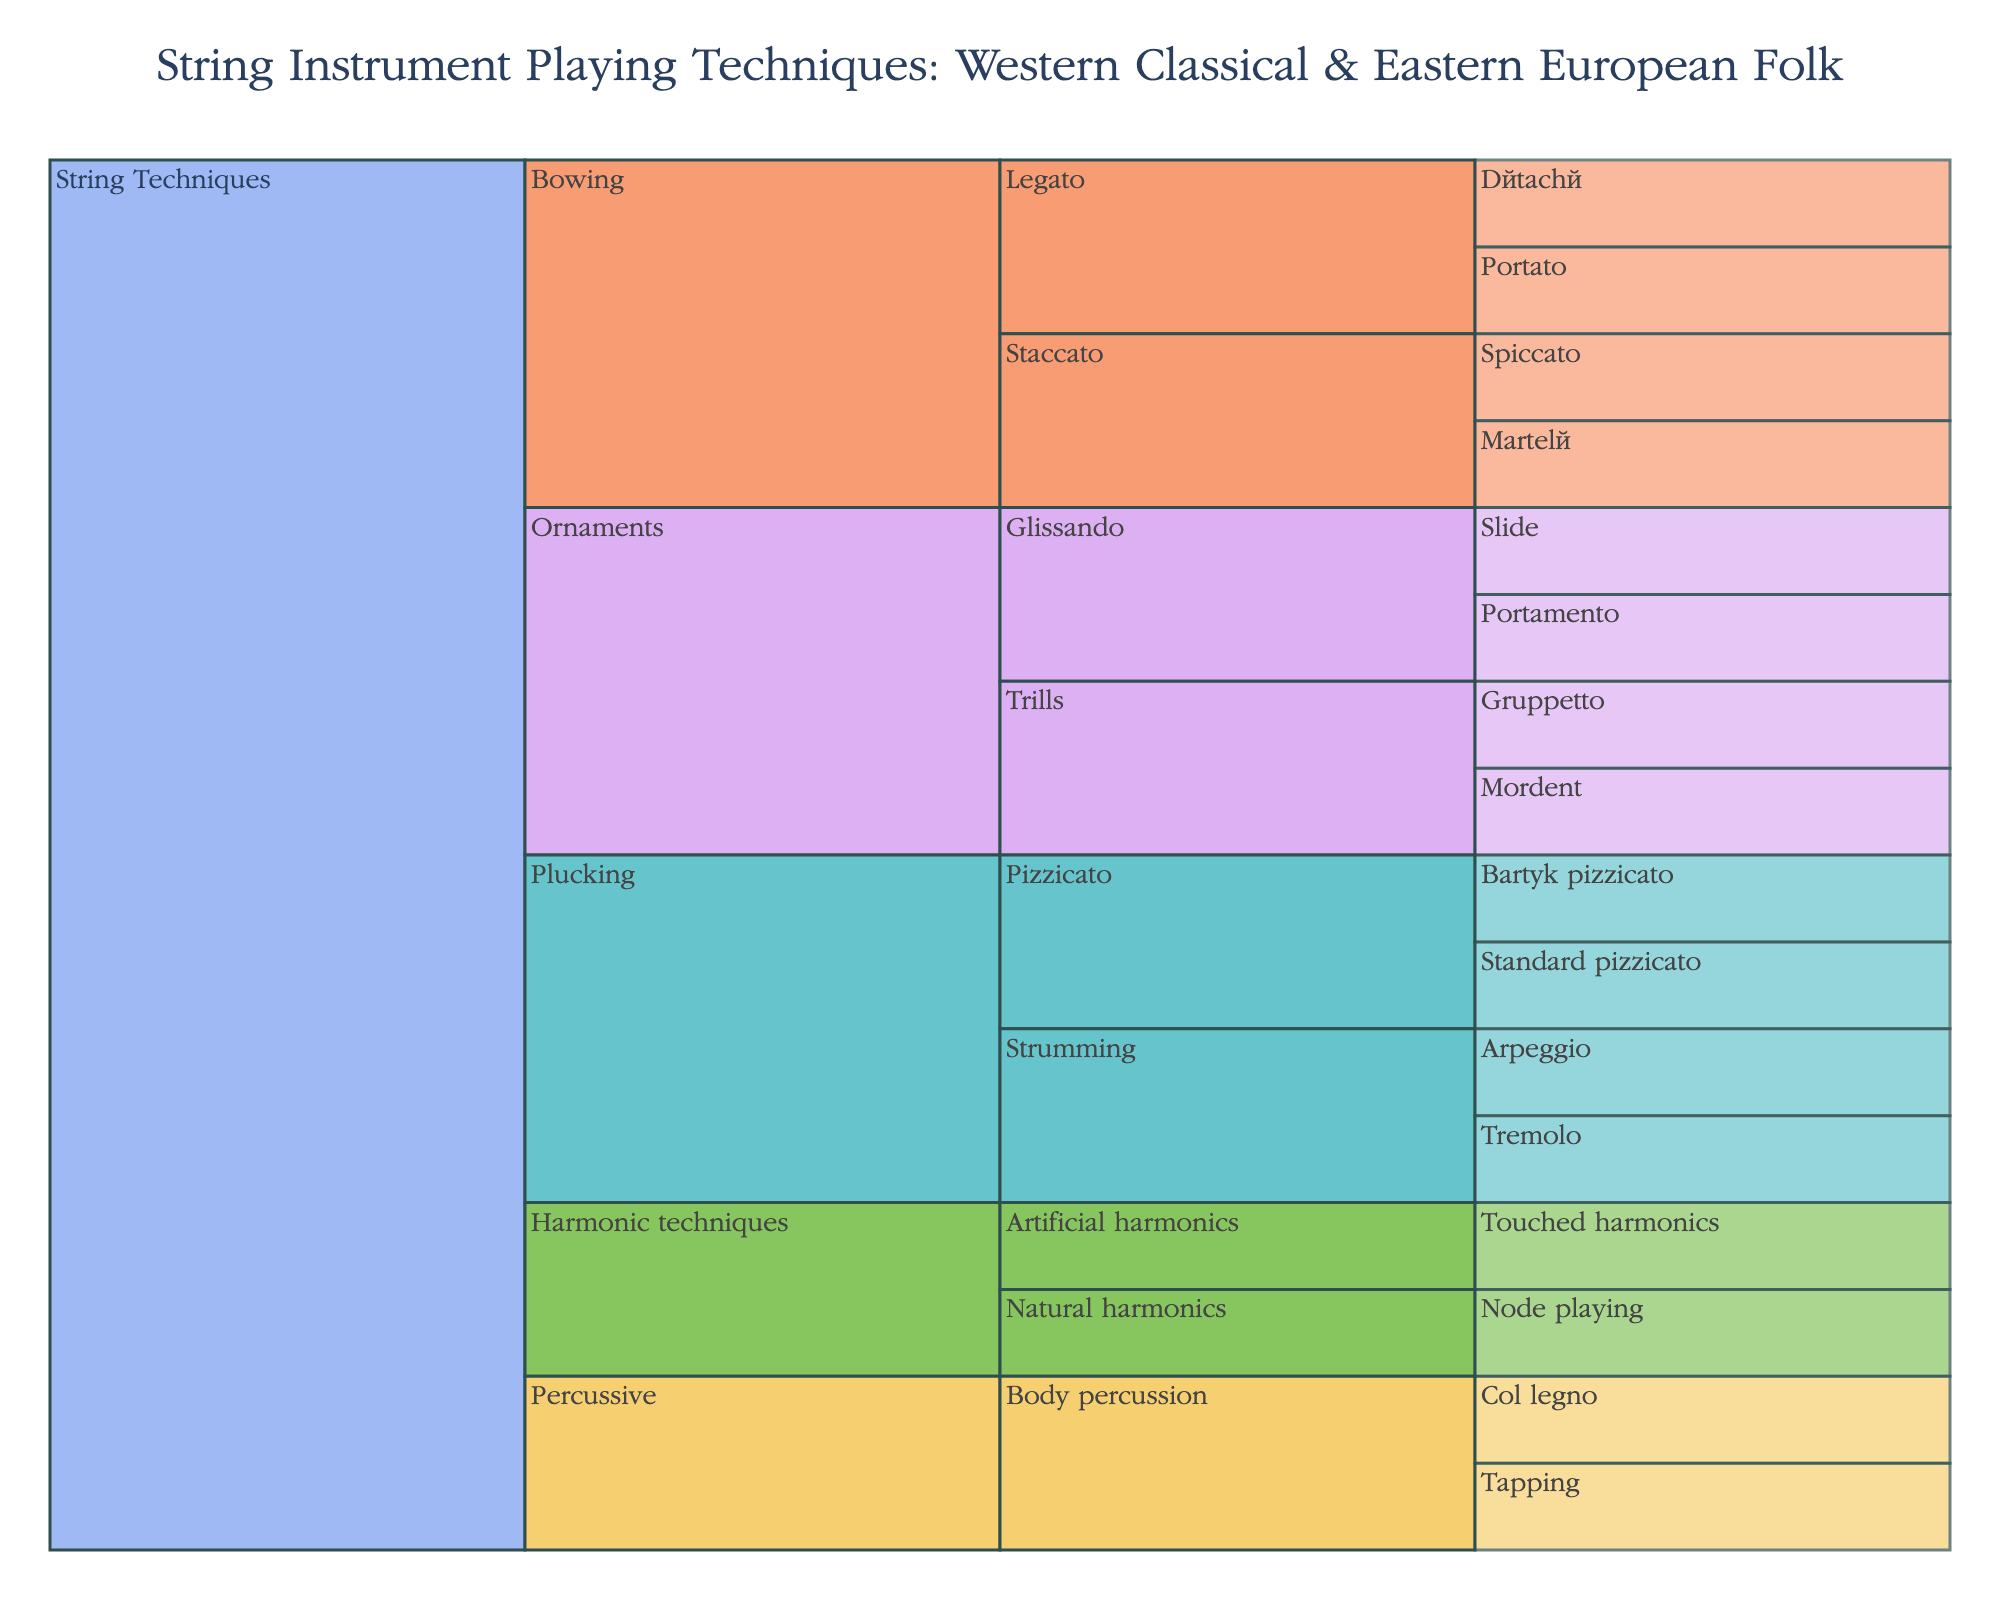What is the title of the figure? The title is located at the top center of the figure and provides a summary of what the figure represents.
Answer: String Instrument Playing Techniques: Western Classical & Eastern European Folk How many main categories of string techniques are shown? There are main categories directly connected to the 'Root' node in the icicle chart. Count these categories to find the answer.
Answer: Four Which subcategory under 'Plucking' has the most detailed techniques listed? Look under the 'Plucking' category and compare the number of techniques listed under each subcategory.
Answer: Pizzicato Are there more techniques listed under 'Bowing' or 'Ornaments'? Compare the total number of techniques listed under the 'Bowing' category and the 'Ornaments' category by counting each technique.
Answer: Bowing What are the techniques listed under 'Percussive' category? Expand the 'Percussive' category by following the branches to each technique listed.
Answer: Col legno, Tapping Which category has 'Natural harmonics' as a subcategory? Identify the main category connected by following the 'Natural harmonics' path.
Answer: Harmonic techniques How many techniques are shared under the 'Bowing' category? Count all the techniques listed under the 'Bowing' category, including both 'Legato' and 'Staccato' subcategories.
Answer: Four Is there a technique listed in the 'Ornaments' category that also appears under any other main category? Review the techniques listed under 'Ornaments' and compare them with techniques in other main categories to find any overlaps.
Answer: No Which specific technique in the 'Plucking' category is unique to Eastern European folk music traditions compared to Western classical music? Identify 'Bartók pizzicato' under the 'Pizzicato' subcategory, which is distinct to Eastern European folk music.
Answer: Bartók pizzicato 